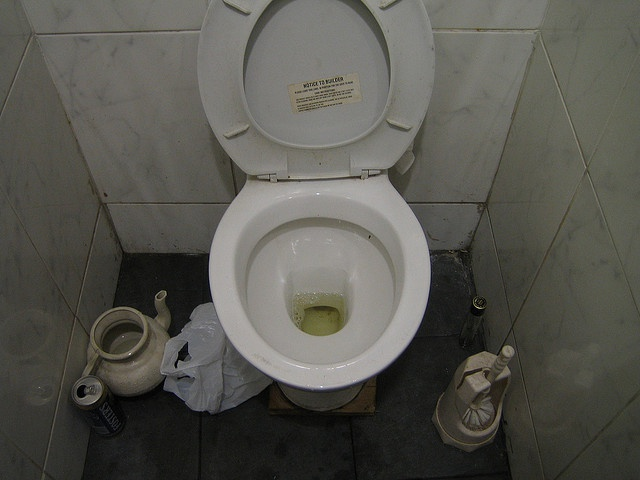Describe the objects in this image and their specific colors. I can see toilet in gray and darkgray tones and bottle in gray, black, darkgreen, and olive tones in this image. 